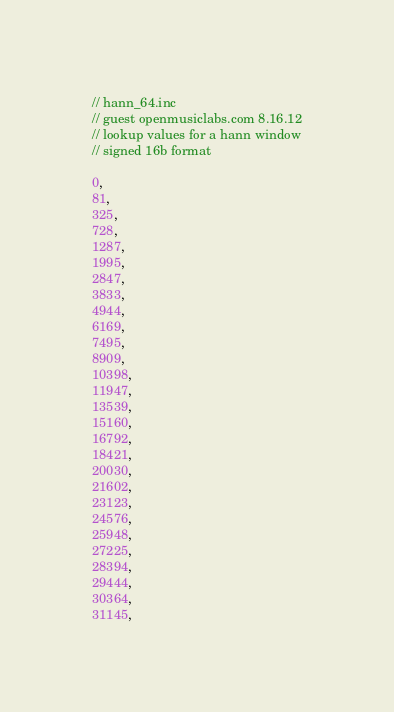<code> <loc_0><loc_0><loc_500><loc_500><_C_>// hann_64.inc
// guest openmusiclabs.com 8.16.12
// lookup values for a hann window
// signed 16b format

0,
81,
325,
728,
1287,
1995,
2847,
3833,
4944,
6169,
7495,
8909,
10398,
11947,
13539,
15160,
16792,
18421,
20030,
21602,
23123,
24576,
25948,
27225,
28394,
29444,
30364,
31145,</code> 